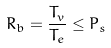Convert formula to latex. <formula><loc_0><loc_0><loc_500><loc_500>R _ { b } = \frac { T _ { v } } { T _ { e } } \leq P _ { s }</formula> 